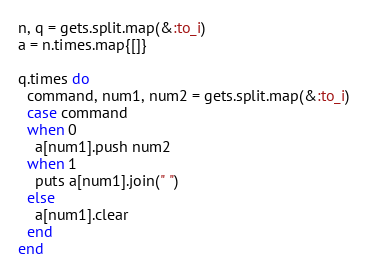<code> <loc_0><loc_0><loc_500><loc_500><_Ruby_>n, q = gets.split.map(&:to_i)
a = n.times.map{[]}

q.times do
  command, num1, num2 = gets.split.map(&:to_i)
  case command
  when 0
    a[num1].push num2
  when 1
    puts a[num1].join(" ")
  else
    a[num1].clear
  end
end
</code> 